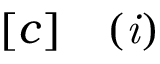Convert formula to latex. <formula><loc_0><loc_0><loc_500><loc_500>\begin{array} { r l } { [ c ] } & ( i ) } \end{array}</formula> 